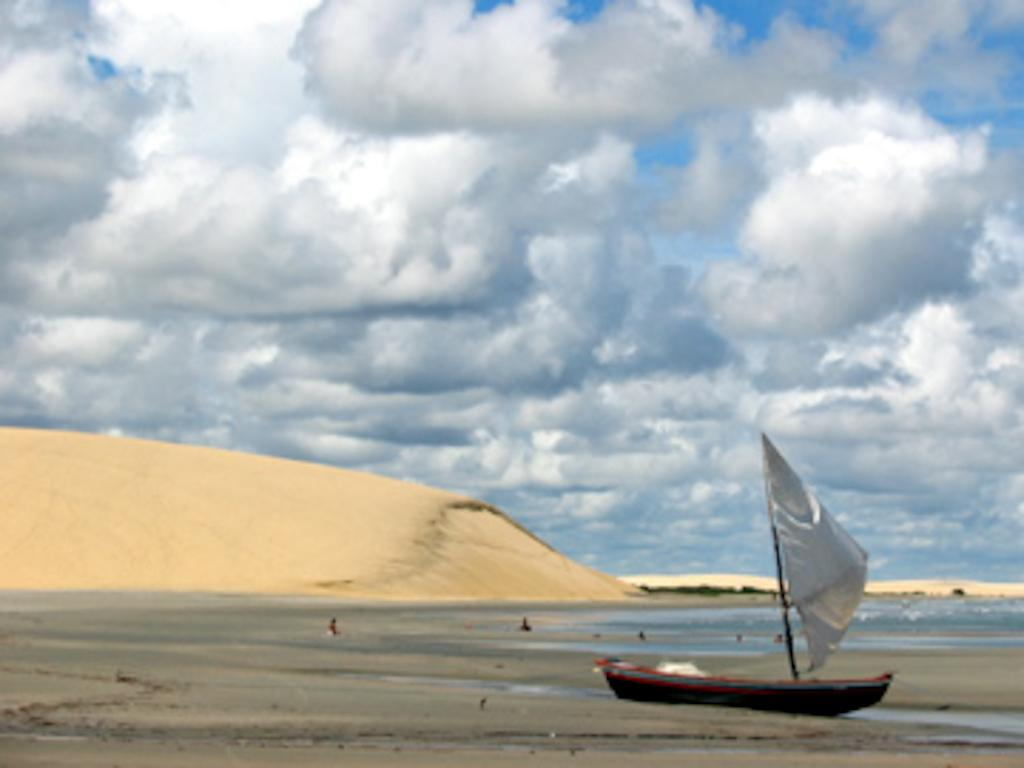What is the main subject of the image? There is a boat in the image. Are there any people in the image? Yes, there are people in the image. What can be seen at the bottom of the image? There is water and sand visible at the bottom of the image. What is visible in the sky at the top of the image? There are clouds in the sky at the top of the image. Can you read the letter that the boat is carrying in the image? There is no letter visible in the image; it only shows a boat, people, water, sand, and clouds. Is there a string attached to the boat in the image? There is no string attached to the boat in the image. 